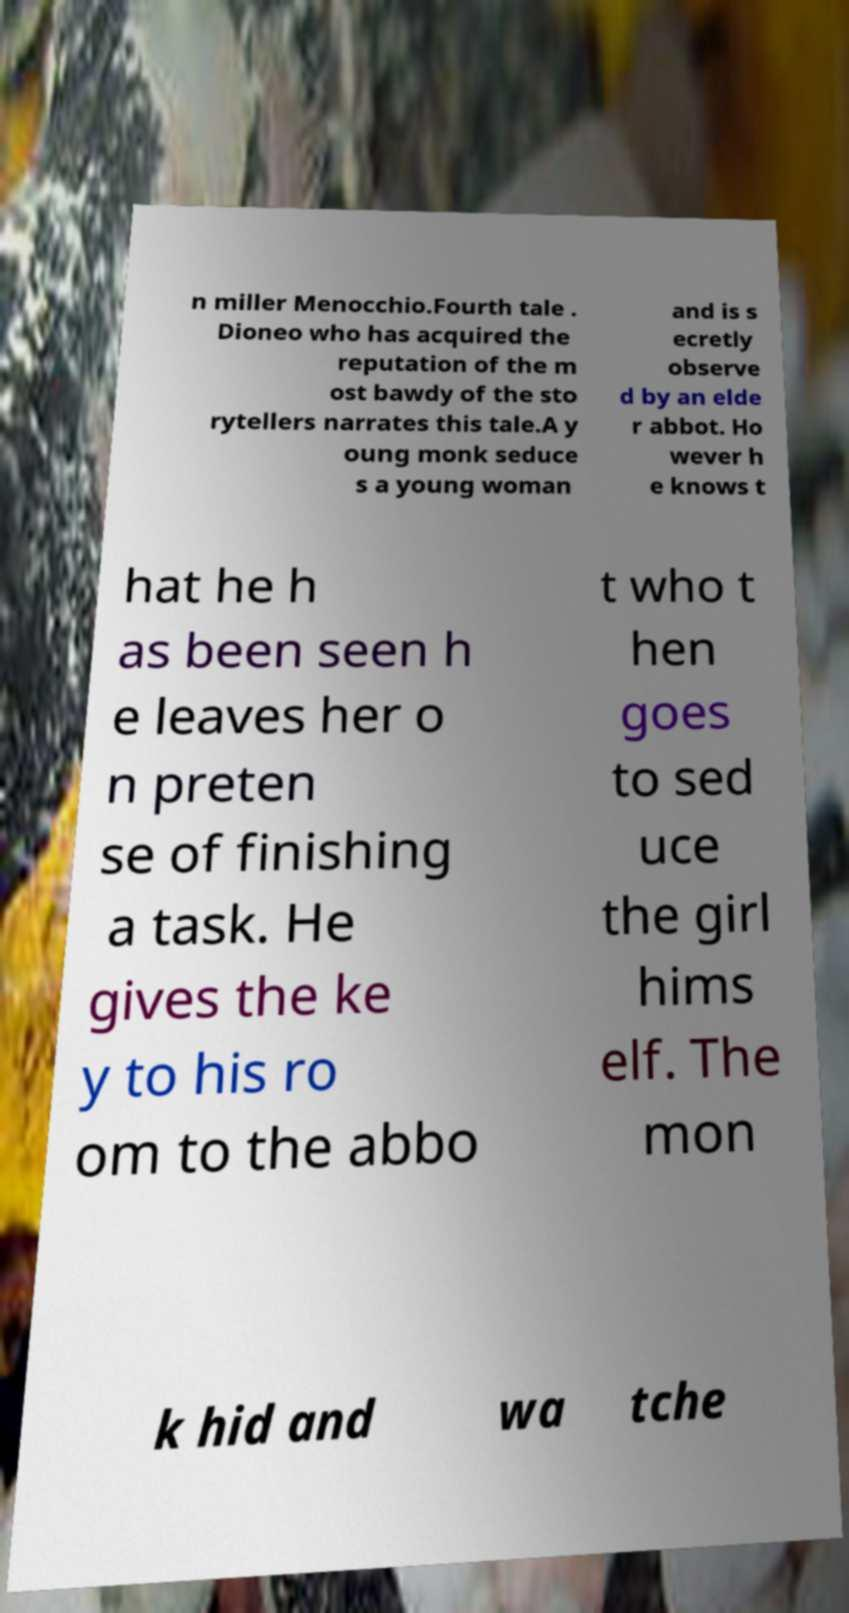What messages or text are displayed in this image? I need them in a readable, typed format. n miller Menocchio.Fourth tale . Dioneo who has acquired the reputation of the m ost bawdy of the sto rytellers narrates this tale.A y oung monk seduce s a young woman and is s ecretly observe d by an elde r abbot. Ho wever h e knows t hat he h as been seen h e leaves her o n preten se of finishing a task. He gives the ke y to his ro om to the abbo t who t hen goes to sed uce the girl hims elf. The mon k hid and wa tche 